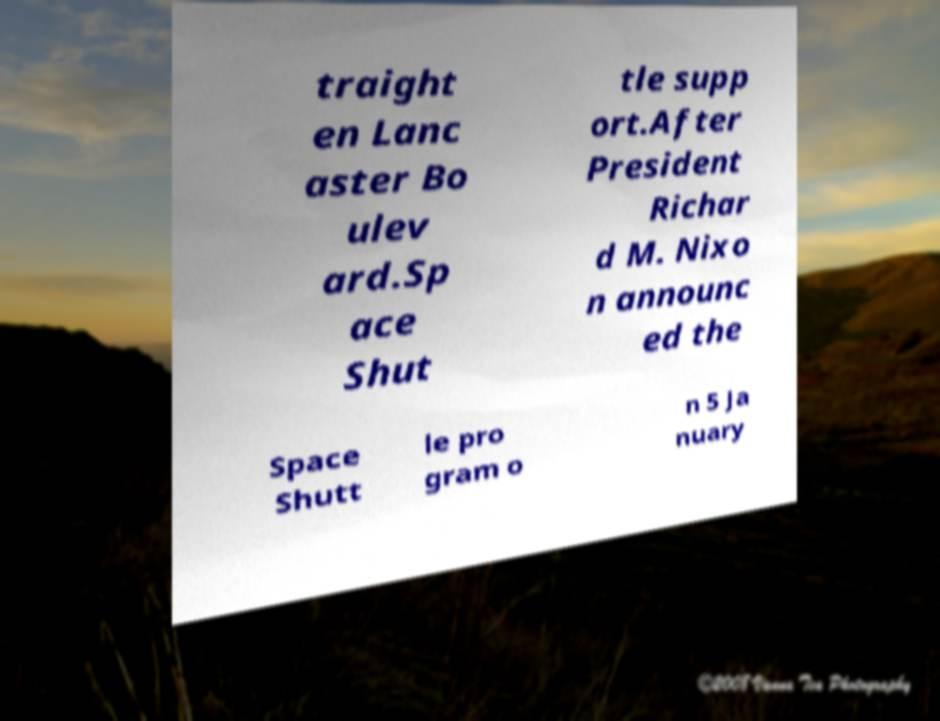Can you read and provide the text displayed in the image?This photo seems to have some interesting text. Can you extract and type it out for me? traight en Lanc aster Bo ulev ard.Sp ace Shut tle supp ort.After President Richar d M. Nixo n announc ed the Space Shutt le pro gram o n 5 Ja nuary 